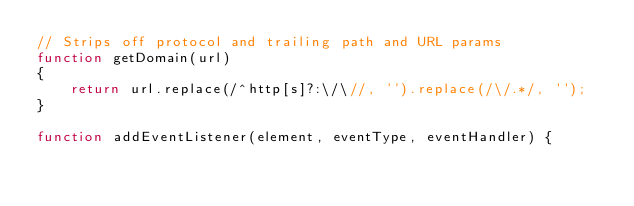<code> <loc_0><loc_0><loc_500><loc_500><_JavaScript_>// Strips off protocol and trailing path and URL params
function getDomain(url)
{
    return url.replace(/^http[s]?:\/\//, '').replace(/\/.*/, '');
}

function addEventListener(element, eventType, eventHandler) {</code> 